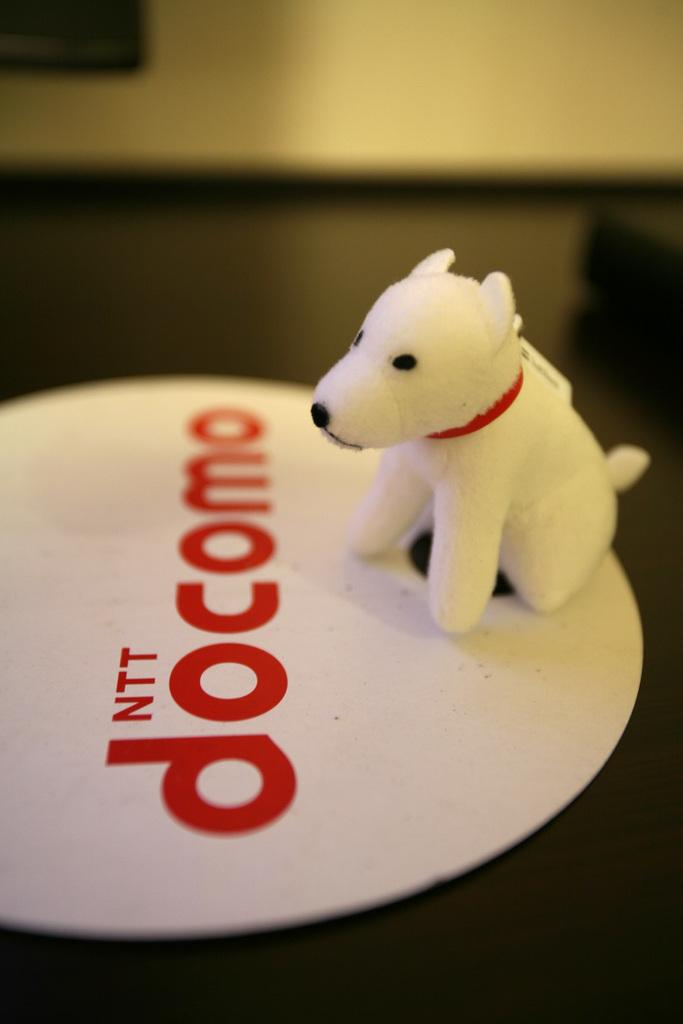What type of object is in the shape of an animal in the image? There is a toy in the shape of an animal in the image. What is the toy placed on? The toy is on a white object. What color is the surface beneath the white object? The surface beneath the white object is black. How would you describe the background of the image? The background of the image is blurred. What type of cherries can be seen growing in the background of the image? There are no cherries present in the image, and the background is blurred, so it is not possible to see any growing cherries. 